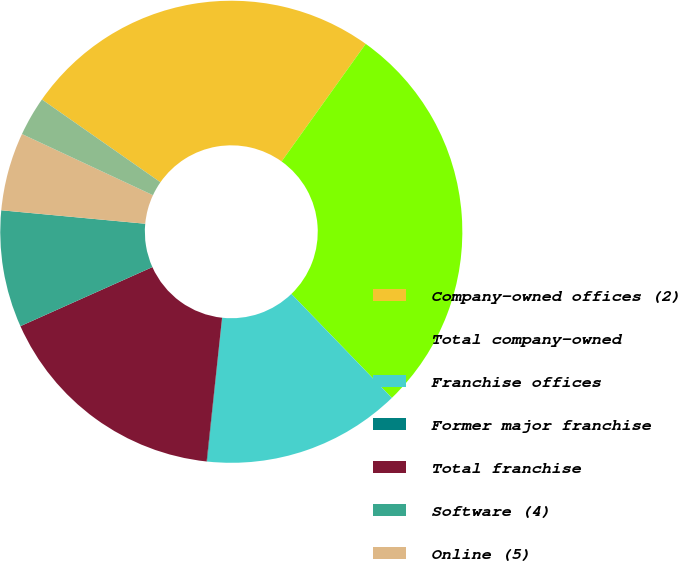Convert chart. <chart><loc_0><loc_0><loc_500><loc_500><pie_chart><fcel>Company-owned offices (2)<fcel>Total company-owned<fcel>Franchise offices<fcel>Former major franchise<fcel>Total franchise<fcel>Software (4)<fcel>Online (5)<fcel>Online<nl><fcel>25.18%<fcel>27.89%<fcel>13.89%<fcel>0.04%<fcel>16.6%<fcel>8.18%<fcel>5.47%<fcel>2.75%<nl></chart> 